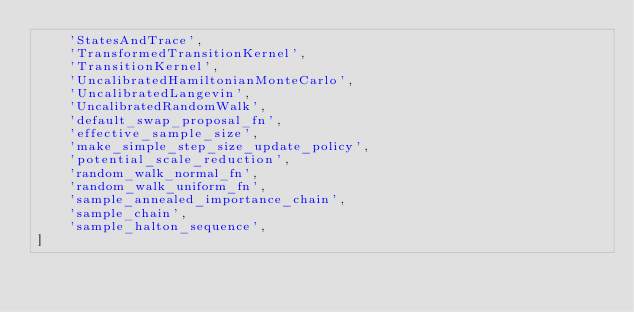Convert code to text. <code><loc_0><loc_0><loc_500><loc_500><_Python_>    'StatesAndTrace',
    'TransformedTransitionKernel',
    'TransitionKernel',
    'UncalibratedHamiltonianMonteCarlo',
    'UncalibratedLangevin',
    'UncalibratedRandomWalk',
    'default_swap_proposal_fn',
    'effective_sample_size',
    'make_simple_step_size_update_policy',
    'potential_scale_reduction',
    'random_walk_normal_fn',
    'random_walk_uniform_fn',
    'sample_annealed_importance_chain',
    'sample_chain',
    'sample_halton_sequence',
]
</code> 